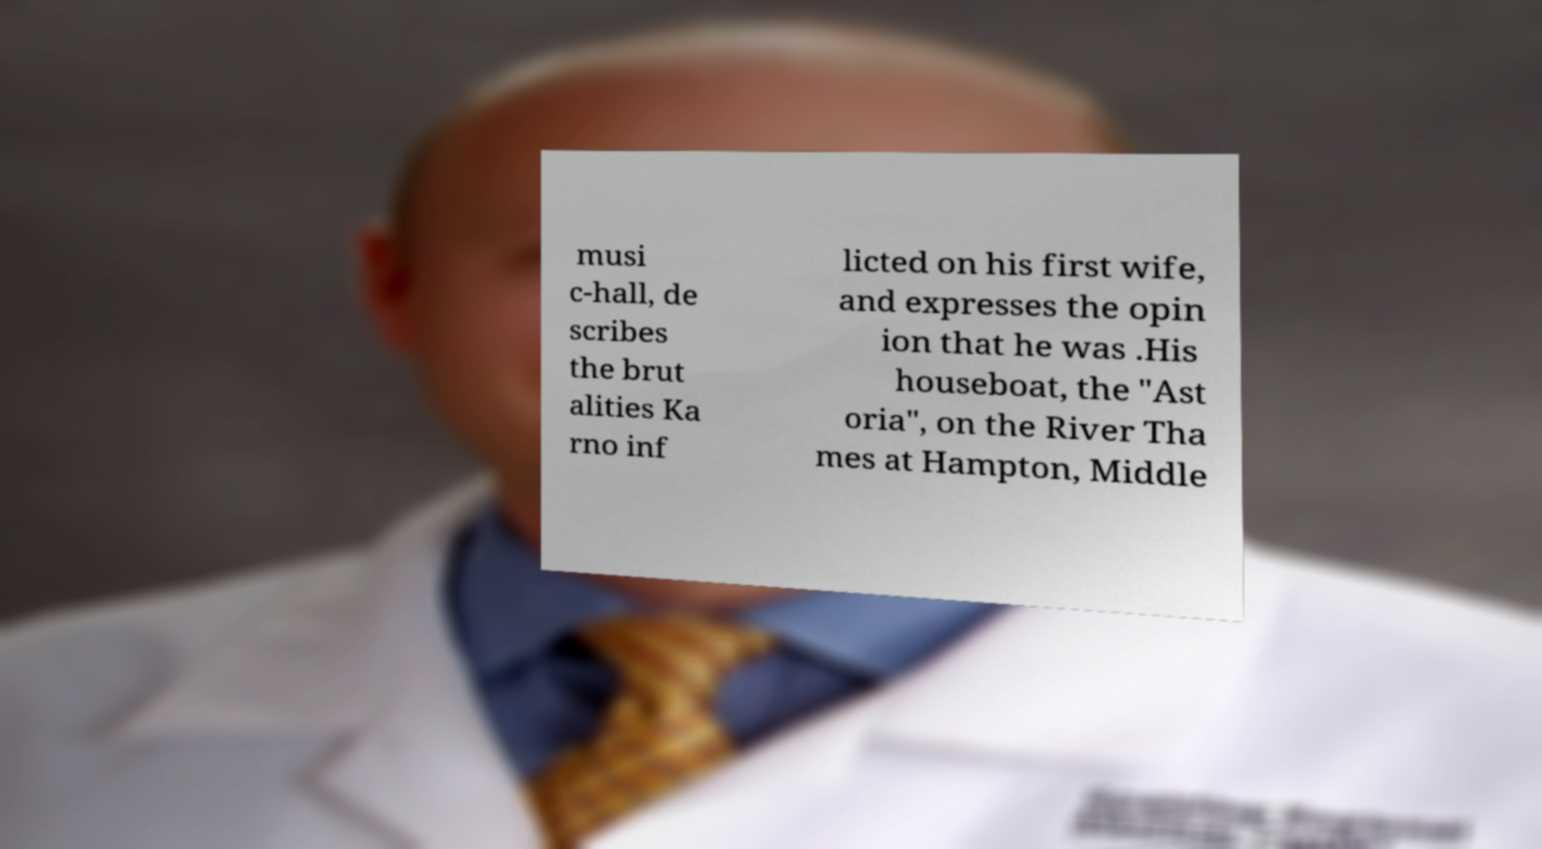There's text embedded in this image that I need extracted. Can you transcribe it verbatim? musi c-hall, de scribes the brut alities Ka rno inf licted on his first wife, and expresses the opin ion that he was .His houseboat, the "Ast oria", on the River Tha mes at Hampton, Middle 